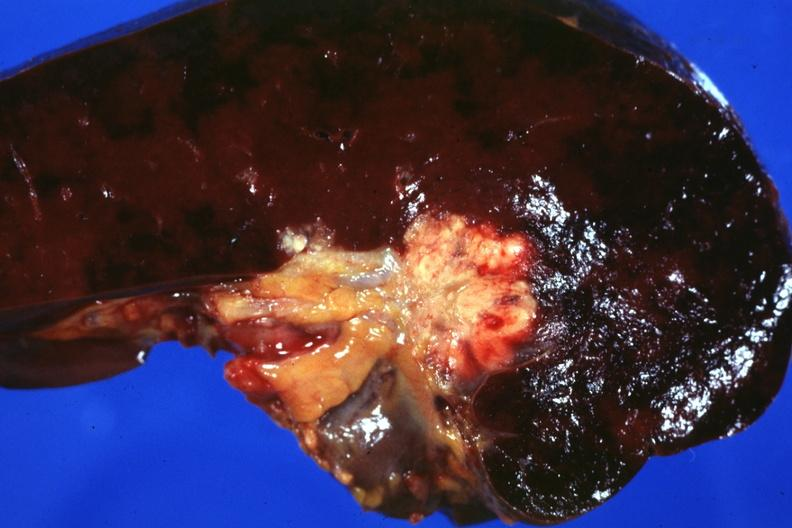how does this photo make one wonder whether metastases spread into the spleen in this case?
Answer the question using a single word or phrase. Node 